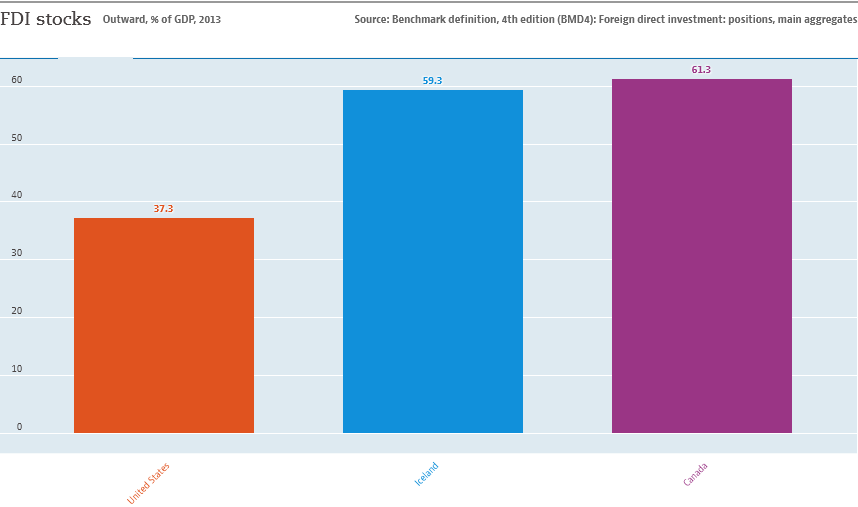Outline some significant characteristics in this image. The value of the highest bar is 61.3. The total sum of foreign direct investment (FDI) stocks in Canada and Ireland is 120.6 billion U.S. dollars. 